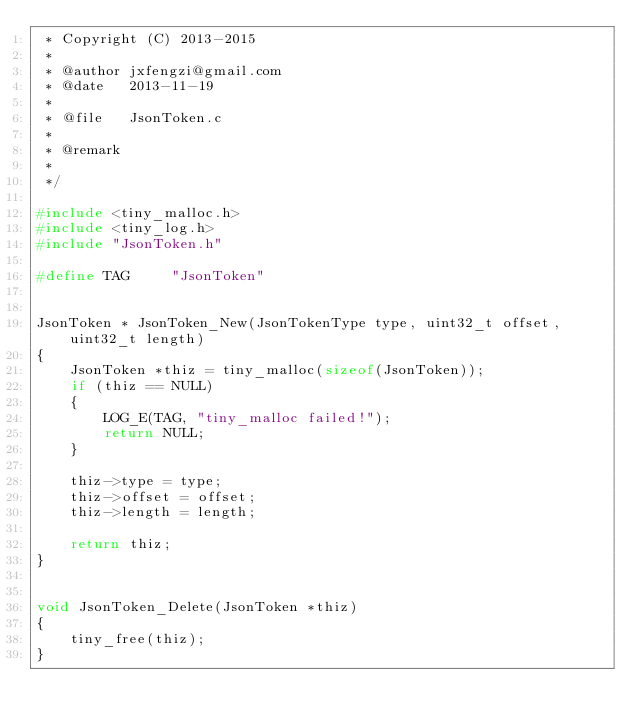Convert code to text. <code><loc_0><loc_0><loc_500><loc_500><_C_> * Copyright (C) 2013-2015
 *
 * @author jxfengzi@gmail.com
 * @date   2013-11-19
 *
 * @file   JsonToken.c
 *
 * @remark
 *
 */

#include <tiny_malloc.h>
#include <tiny_log.h>
#include "JsonToken.h"

#define TAG     "JsonToken"


JsonToken * JsonToken_New(JsonTokenType type, uint32_t offset, uint32_t length)
{
    JsonToken *thiz = tiny_malloc(sizeof(JsonToken));
    if (thiz == NULL)
    {
        LOG_E(TAG, "tiny_malloc failed!");
        return NULL;
    }

    thiz->type = type;
    thiz->offset = offset;
    thiz->length = length;

    return thiz;
}


void JsonToken_Delete(JsonToken *thiz)
{
    tiny_free(thiz);
}
</code> 